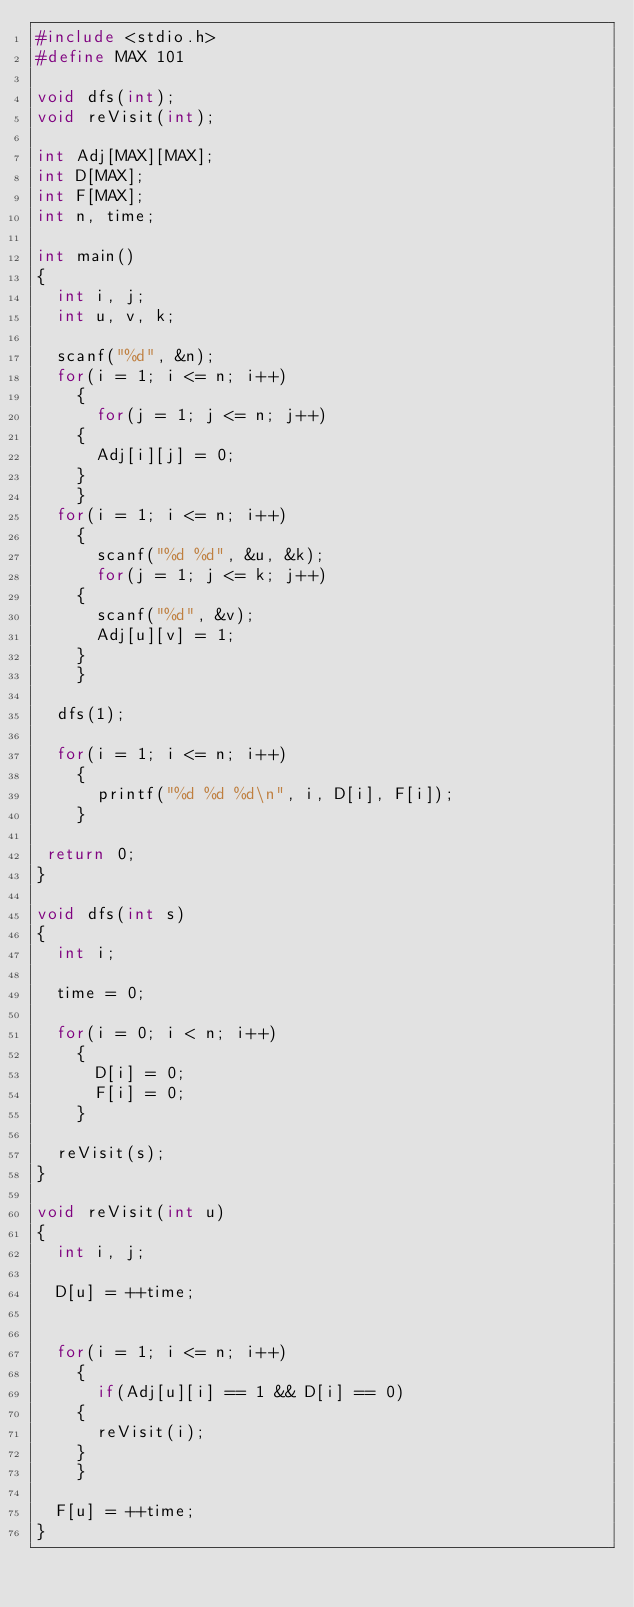Convert code to text. <code><loc_0><loc_0><loc_500><loc_500><_C_>#include <stdio.h>
#define MAX 101

void dfs(int);
void reVisit(int);

int Adj[MAX][MAX];
int D[MAX];
int F[MAX];
int n, time;

int main()
{
  int i, j;
  int u, v, k;

  scanf("%d", &n);
  for(i = 1; i <= n; i++)
    {
      for(j = 1; j <= n; j++)
	{
	  Adj[i][j] = 0;
	}
    }
  for(i = 1; i <= n; i++)
    {
      scanf("%d %d", &u, &k);
      for(j = 1; j <= k; j++)
	{
	  scanf("%d", &v);
	  Adj[u][v] = 1;
	}
    }

  dfs(1);

  for(i = 1; i <= n; i++)
    {
      printf("%d %d %d\n", i, D[i], F[i]);
    }

 return 0;
}

void dfs(int s)
{
  int i;

  time = 0;

  for(i = 0; i < n; i++)
    {
      D[i] = 0;
      F[i] = 0;
    }

  reVisit(s);
}

void reVisit(int u)
{
  int i, j;

  D[u] = ++time;


  for(i = 1; i <= n; i++)
    {
      if(Adj[u][i] == 1 && D[i] == 0)
	{
	  reVisit(i);
	}
    }

  F[u] = ++time;
}</code> 